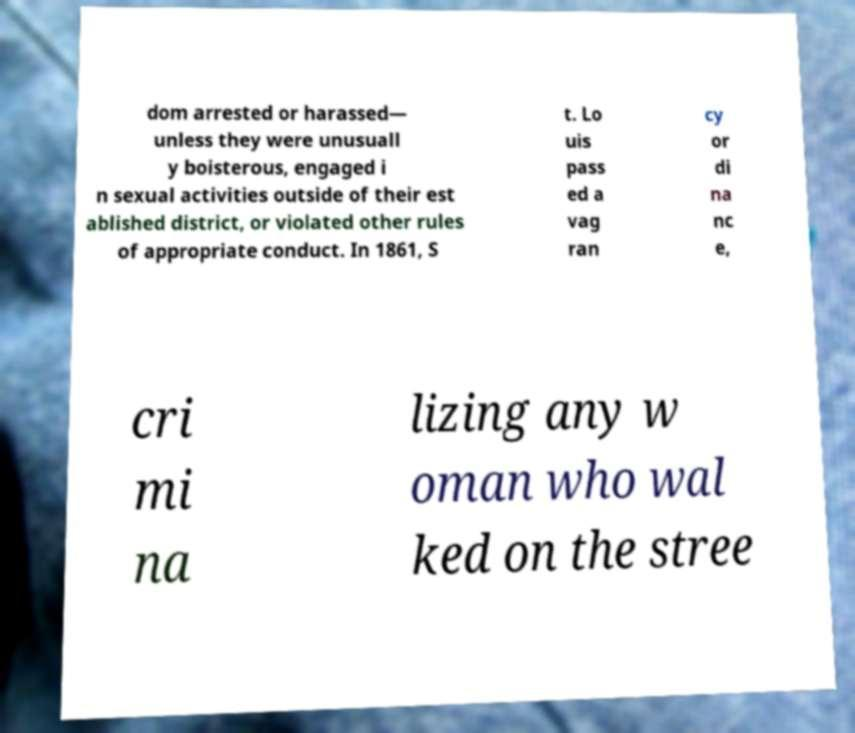Please identify and transcribe the text found in this image. dom arrested or harassed— unless they were unusuall y boisterous, engaged i n sexual activities outside of their est ablished district, or violated other rules of appropriate conduct. In 1861, S t. Lo uis pass ed a vag ran cy or di na nc e, cri mi na lizing any w oman who wal ked on the stree 